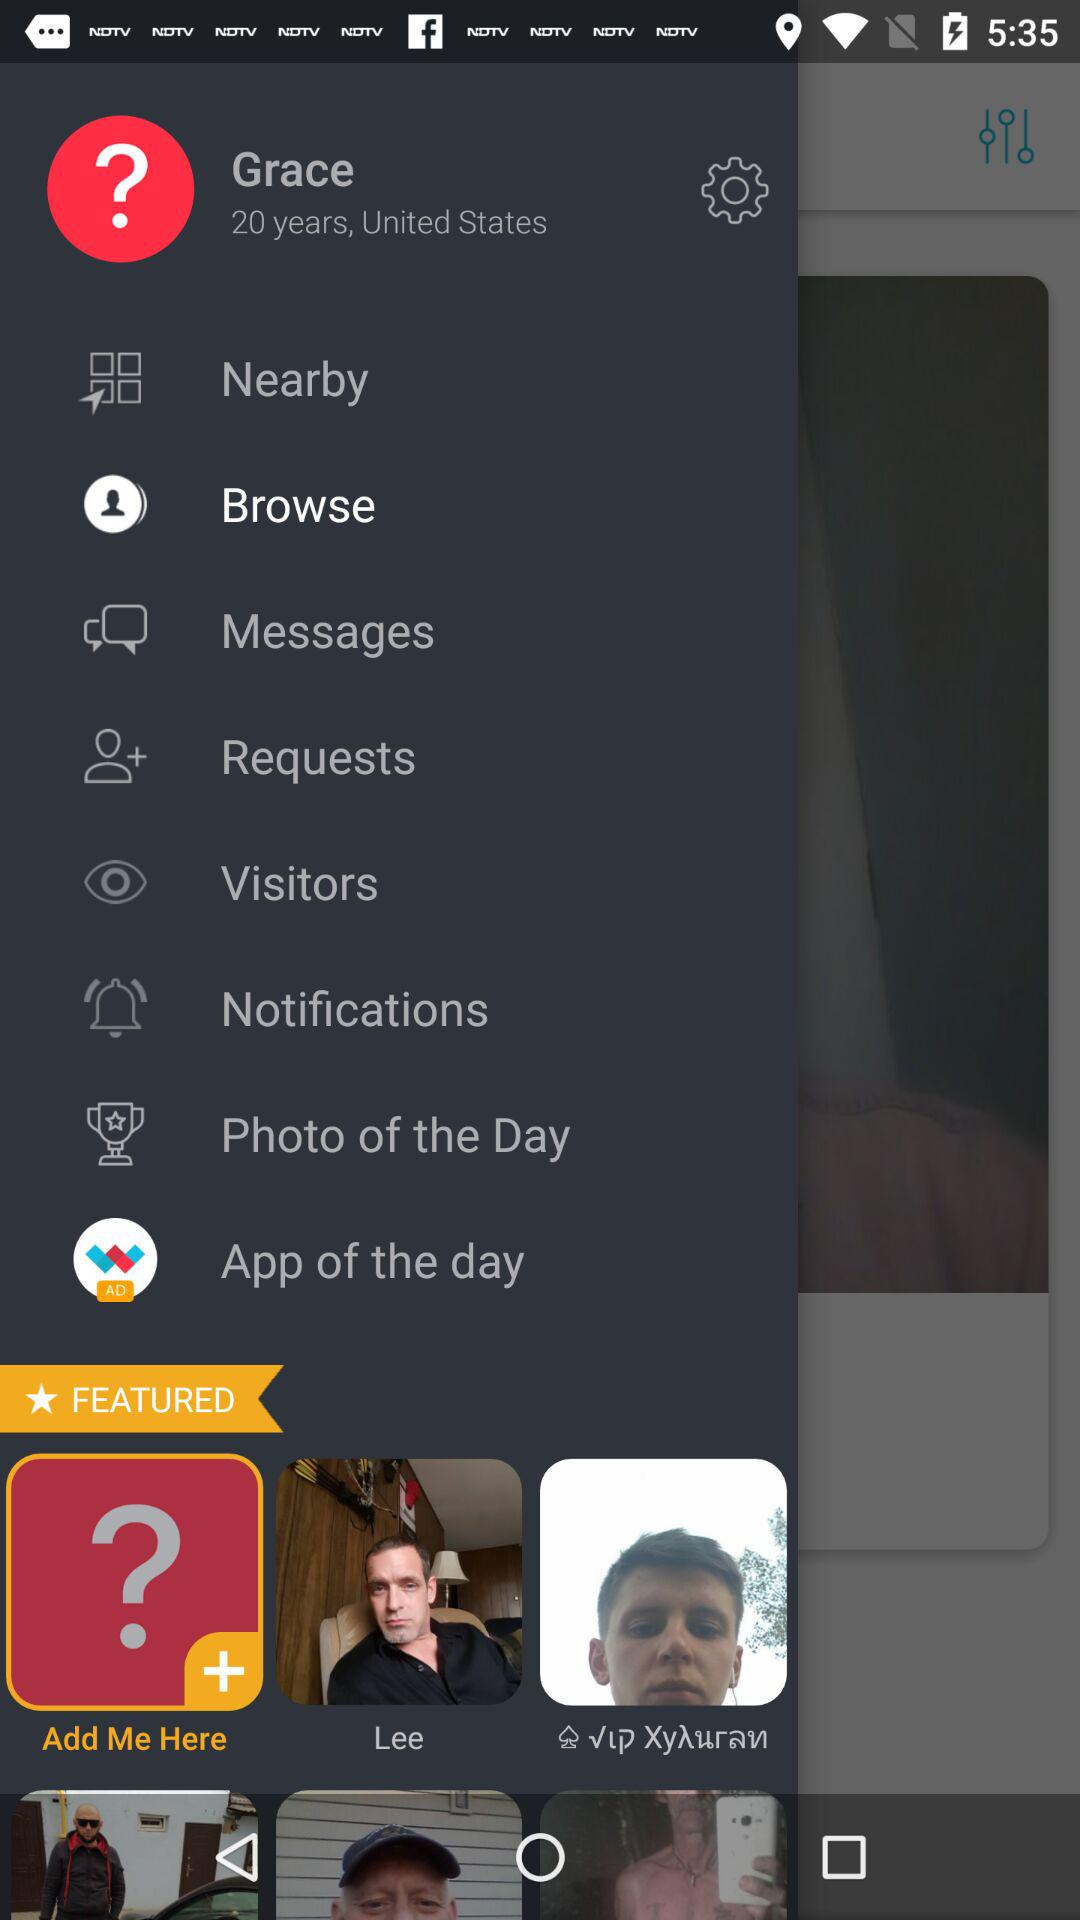What is the age of Grace? The age is 20 years. 